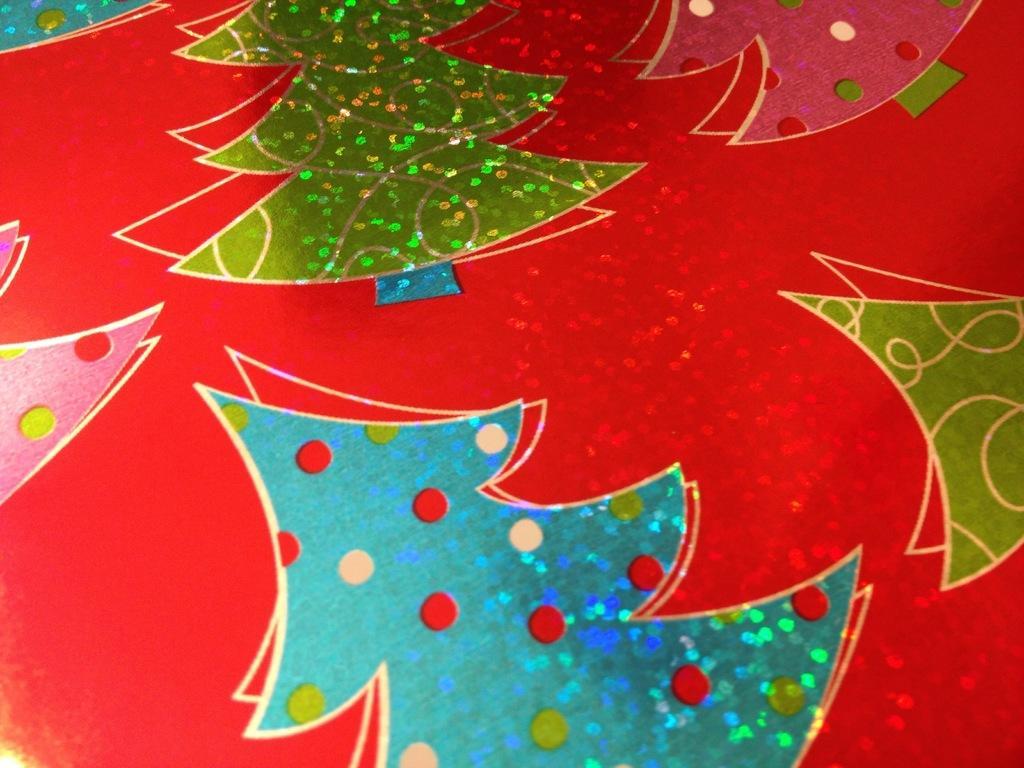How would you summarize this image in a sentence or two? In this image there are glittering Christmas trees on the card. 